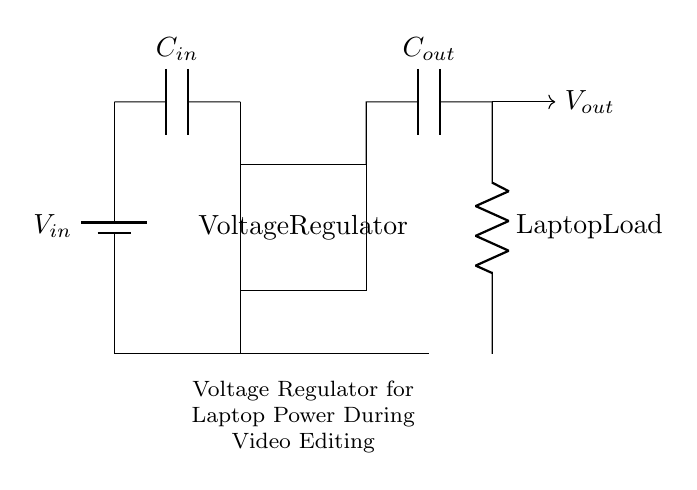What type of capacitor is used at the input? The circuit shows a capacitor labeled C-in connected at the input side, which is the first component after the voltage source. This capacitor stabilizes the input voltage to the regulator.
Answer: C-in What does the rectangle represent in this circuit? The rectangle is labeled as "Voltage Regulator" and represents the main component of the circuit that regulates the output voltage to a stable level suitable for the laptop.
Answer: Voltage Regulator What is the purpose of C-out? The output capacitor (C-out) filters the output voltage from the regulator, smoothing out any fluctuations and providing stable voltage to the laptop load.
Answer: Smoothing What load does the circuit supply power to? After the output capacitor, the circuit further connects to a resistor labeled as "Laptop Load", indicating that this is the device powered by the circuit.
Answer: Laptop Load What is the role of the input capacitor? The input capacitor (C-in) is essential for preventing voltage ripple from the power source, ensuring that the voltage regulator receives a stable input voltage for proper operation.
Answer: Stabilizing input voltage How does the regulator affect the output voltage? The voltage regulator adjusts the voltage to a constant level, regardless of variations in the input voltage, delivering a stable output voltage to the load connected to the circuit.
Answer: Stabilizes voltage 